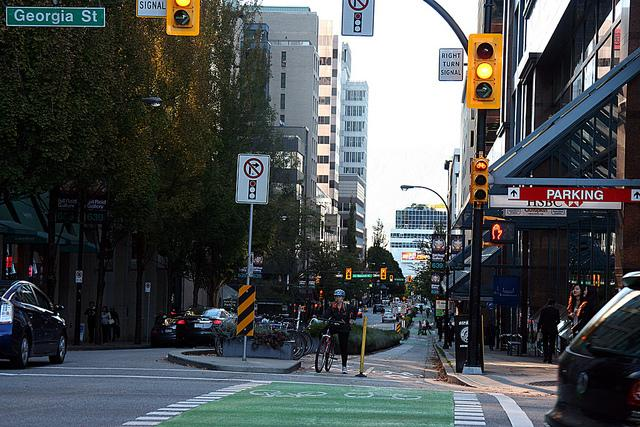What is the lane painted green for?

Choices:
A) minivans only
B) pedestrians only
C) bikes only
D) keep out bikes only 